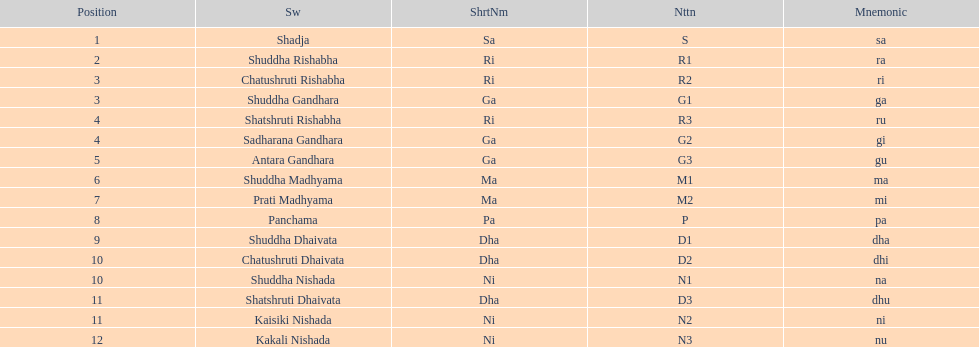What swara is above shatshruti dhaivata? Shuddha Nishada. 